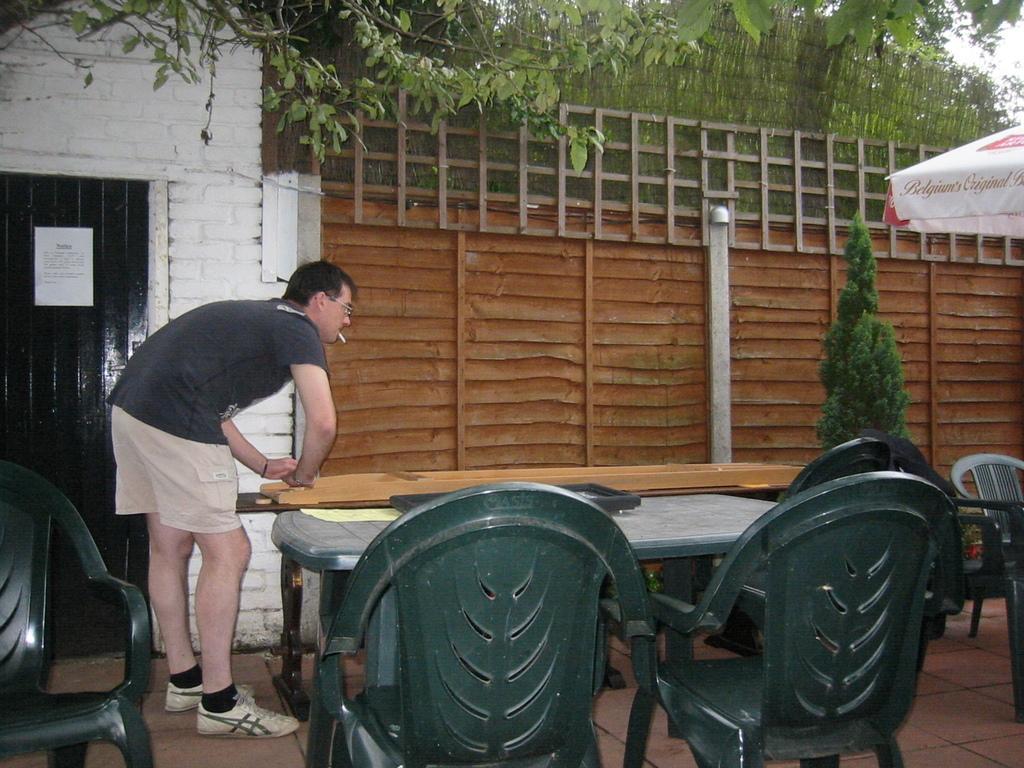Could you give a brief overview of what you see in this image? We can see chairs and tables,there is a person standing and smoking. We can see tent. In the background we can see wall,tree and wooden fence. 